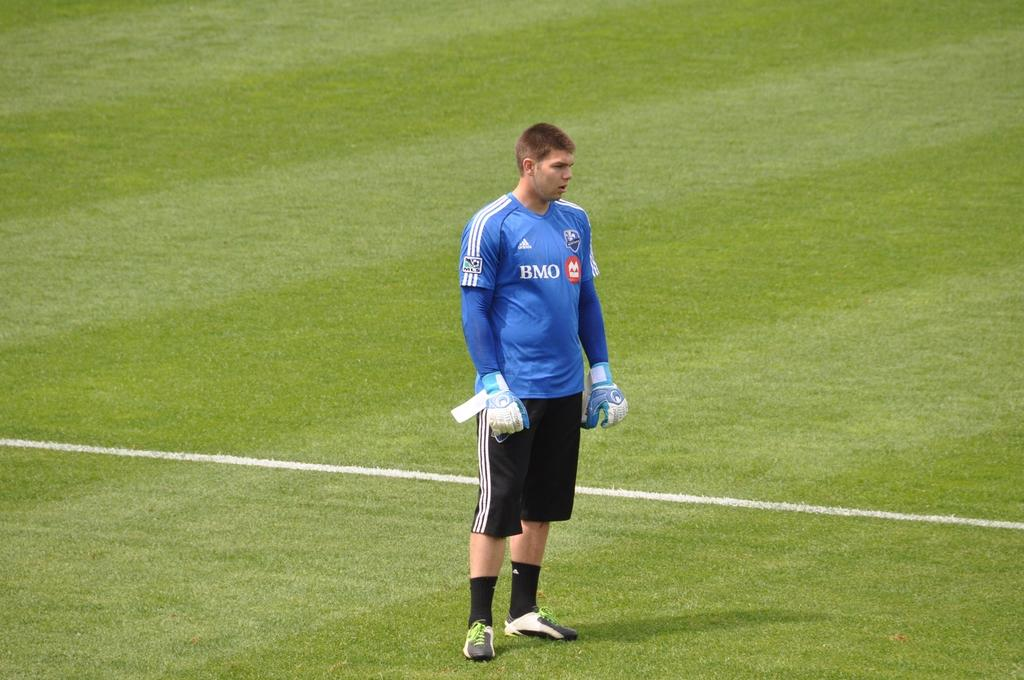<image>
Offer a succinct explanation of the picture presented. A BMO player in a blue jersey stands in the middle of the playing field. 